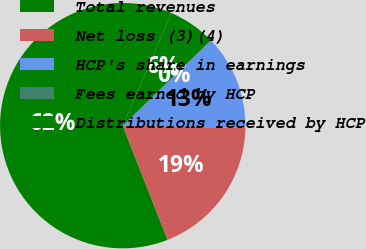Convert chart. <chart><loc_0><loc_0><loc_500><loc_500><pie_chart><fcel>Total revenues<fcel>Net loss (3)(4)<fcel>HCP's share in earnings<fcel>Fees earned by HCP<fcel>Distributions received by HCP<nl><fcel>62.44%<fcel>18.75%<fcel>12.51%<fcel>0.03%<fcel>6.27%<nl></chart> 